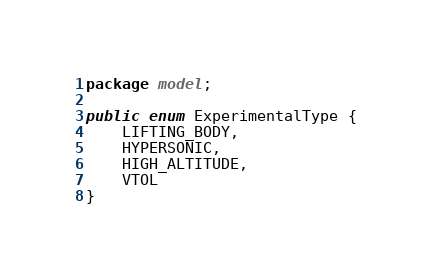Convert code to text. <code><loc_0><loc_0><loc_500><loc_500><_Java_>package model;

public enum ExperimentalType {
    LIFTING_BODY,
    HYPERSONIC,
    HIGH_ALTITUDE,
    VTOL
}
</code> 